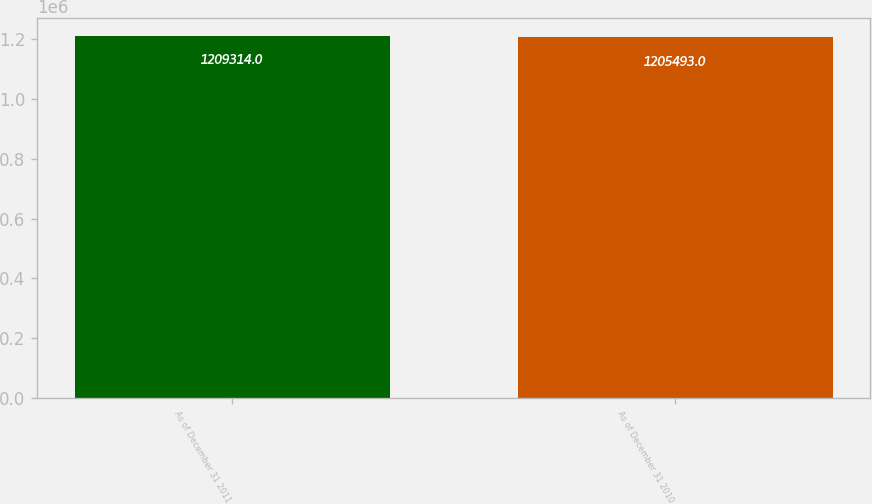<chart> <loc_0><loc_0><loc_500><loc_500><bar_chart><fcel>As of December 31 2011<fcel>As of December 31 2010<nl><fcel>1.20931e+06<fcel>1.20549e+06<nl></chart> 